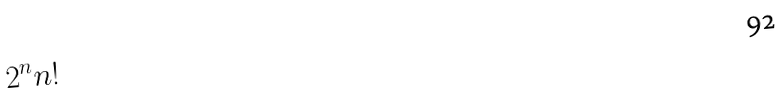Convert formula to latex. <formula><loc_0><loc_0><loc_500><loc_500>2 ^ { n } n !</formula> 